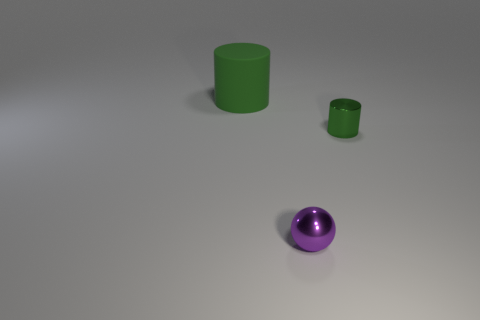What is the color of the small thing that is made of the same material as the small sphere?
Give a very brief answer. Green. What is the material of the small purple sphere?
Provide a succinct answer. Metal. What is the shape of the tiny purple metal object?
Your response must be concise. Sphere. How many rubber cylinders have the same color as the matte thing?
Offer a very short reply. 0. What material is the thing behind the green thing on the right side of the thing that is in front of the small green thing?
Offer a very short reply. Rubber. What number of purple objects are metal things or large matte cylinders?
Give a very brief answer. 1. There is a thing behind the green thing that is in front of the green cylinder that is left of the small green metallic thing; how big is it?
Offer a terse response. Large. There is another metallic object that is the same shape as the large green object; what size is it?
Offer a very short reply. Small. How many big things are gray rubber balls or purple shiny things?
Your response must be concise. 0. Do the green cylinder that is on the right side of the green matte cylinder and the cylinder on the left side of the metal ball have the same material?
Provide a short and direct response. No. 